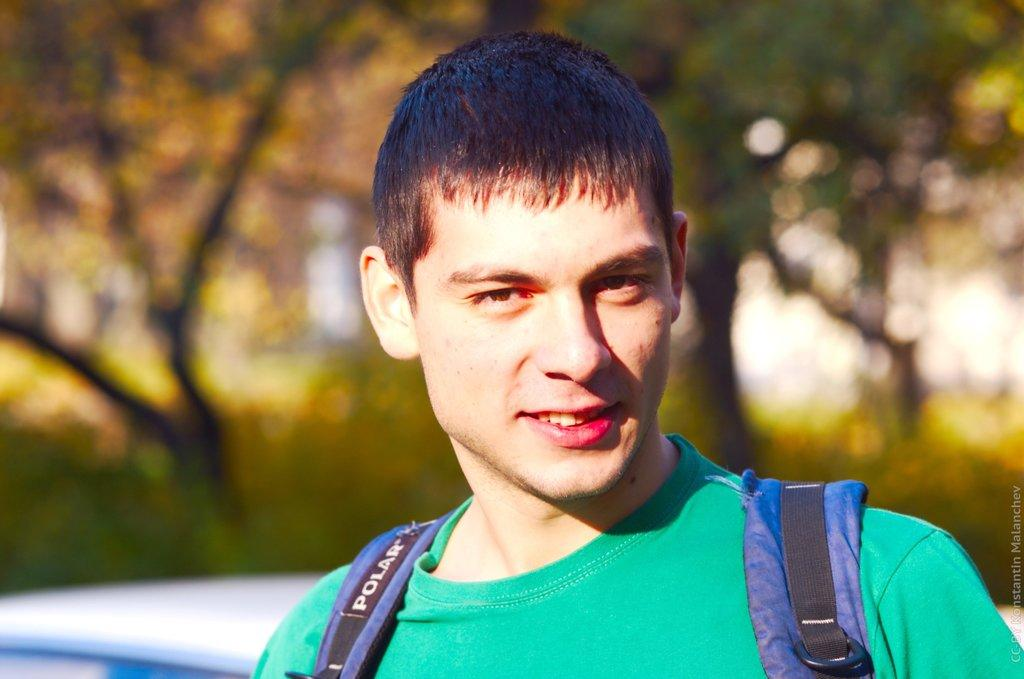Who is the main subject in the picture? There is a man in the picture. Where is the man located in the image? The man is in the middle of the picture. What is the man wearing in the image? The man is wearing a green color T-shirt. Can you describe the background of the image? The background of the image is blurred. What type of sponge can be seen in the man's hand in the image? There is no sponge present in the man's hand or in the image. 